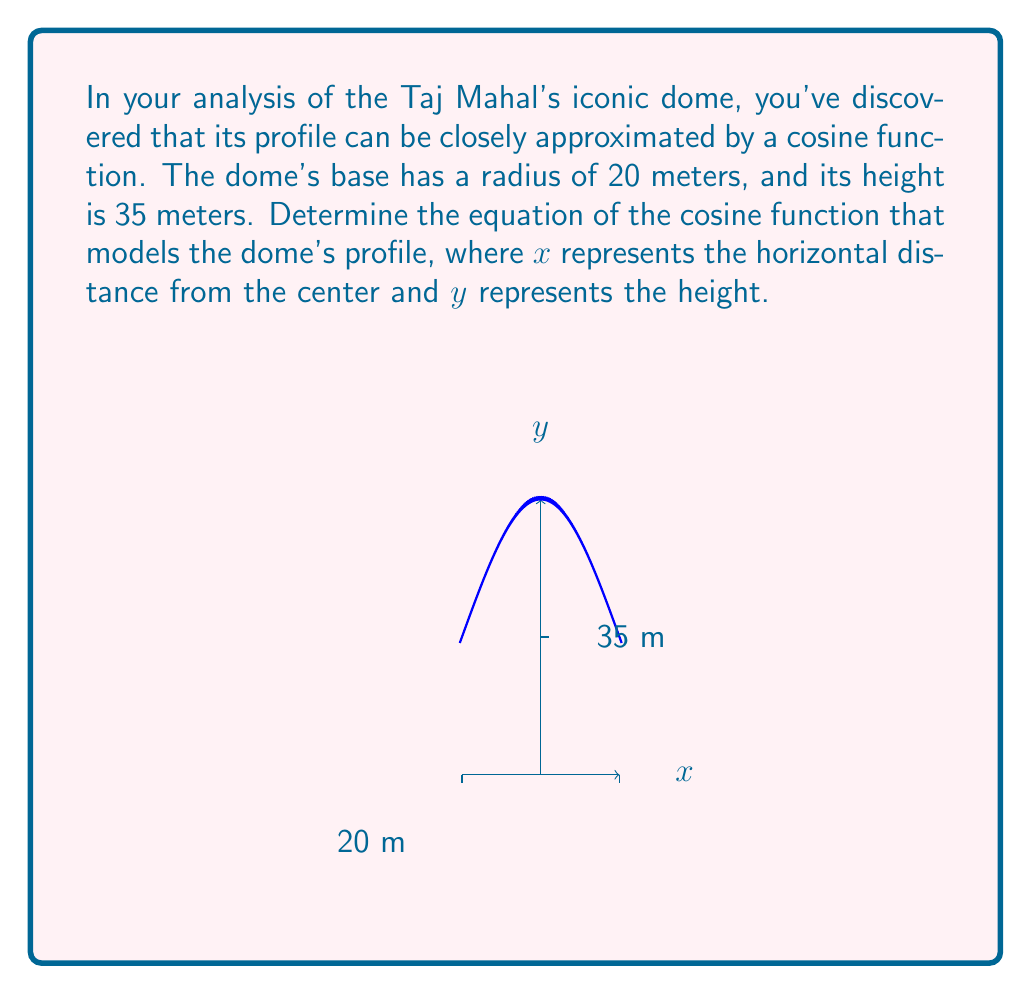Could you help me with this problem? To model the dome's profile with a cosine function, we'll use the general form:

$$y = a \cos(b(x-h)) + k$$

Where:
- $a$ is the amplitude (half the height of the dome)
- $b$ affects the period (width of the dome)
- $h$ is the horizontal shift (0 in this case)
- $k$ is the vertical shift (the height of the dome's center)

Step 1: Determine the amplitude ($a$)
The amplitude is half the height of the dome: $a = 35/2 = 17.5$

Step 2: Determine the vertical shift ($k$)
The center of the dome is at its full height: $k = 35$

Step 3: Determine $b$ using the period
The period of the cosine function should be twice the base radius:
$\text{Period} = 2\pi/b = 40$
$b = 2\pi/40 = \pi/20$

Step 4: Construct the equation
$$y = 17.5 \cos(\frac{\pi}{20}x) + 35$$

This equation models the dome's profile, where $x$ is the horizontal distance from the center (in meters) and $y$ is the height (in meters).
Answer: $y = 17.5 \cos(\frac{\pi}{20}x) + 35$ 